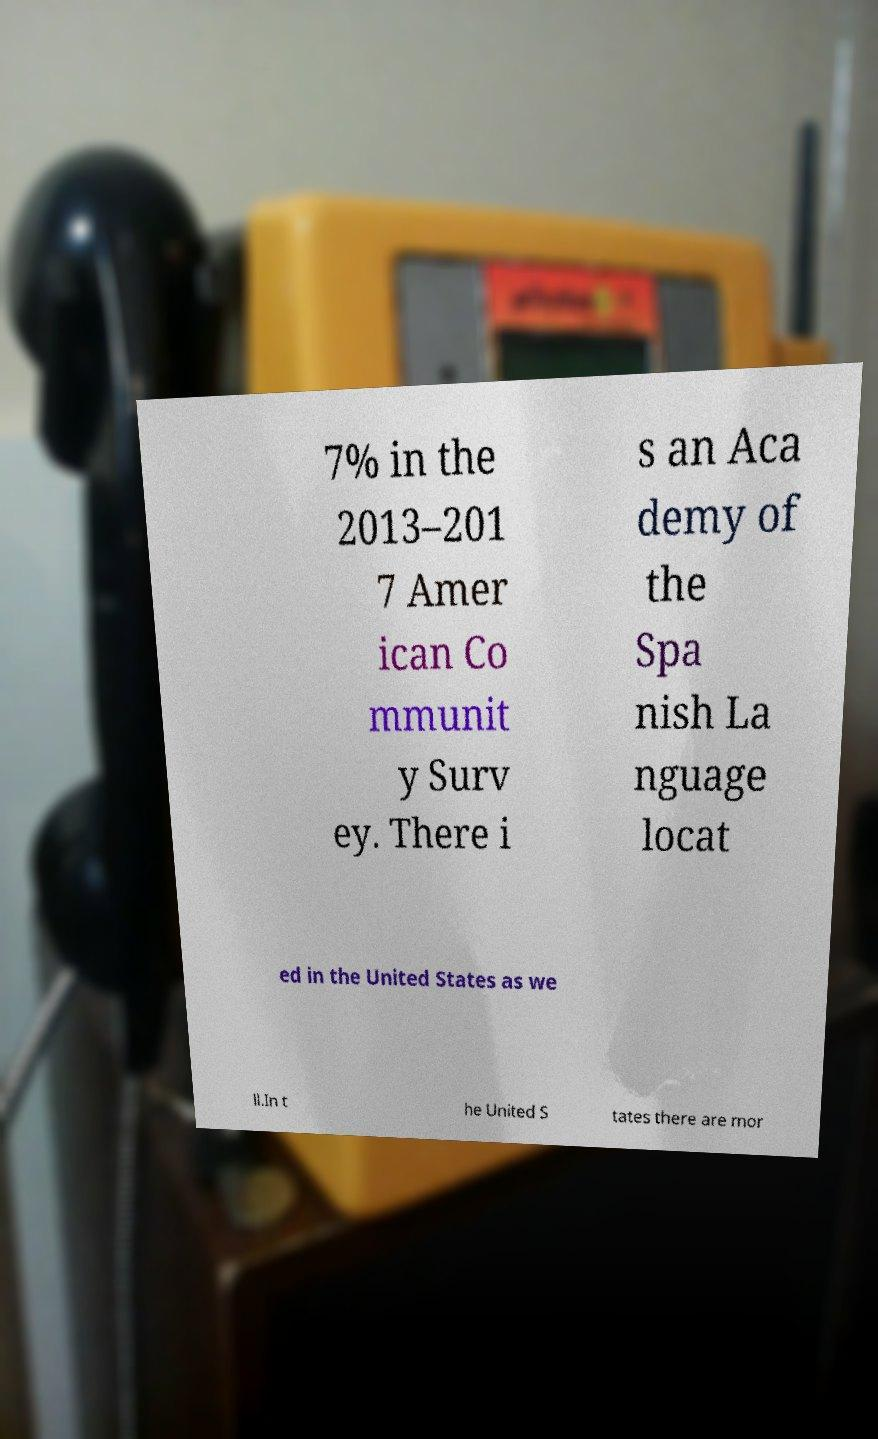Please identify and transcribe the text found in this image. 7% in the 2013–201 7 Amer ican Co mmunit y Surv ey. There i s an Aca demy of the Spa nish La nguage locat ed in the United States as we ll.In t he United S tates there are mor 